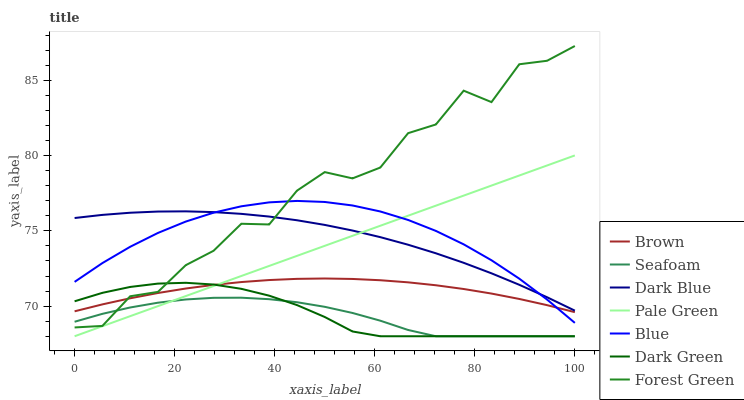Does Seafoam have the minimum area under the curve?
Answer yes or no. Yes. Does Forest Green have the maximum area under the curve?
Answer yes or no. Yes. Does Brown have the minimum area under the curve?
Answer yes or no. No. Does Brown have the maximum area under the curve?
Answer yes or no. No. Is Pale Green the smoothest?
Answer yes or no. Yes. Is Forest Green the roughest?
Answer yes or no. Yes. Is Brown the smoothest?
Answer yes or no. No. Is Brown the roughest?
Answer yes or no. No. Does Brown have the lowest value?
Answer yes or no. No. Does Forest Green have the highest value?
Answer yes or no. Yes. Does Brown have the highest value?
Answer yes or no. No. Is Dark Green less than Blue?
Answer yes or no. Yes. Is Dark Blue greater than Brown?
Answer yes or no. Yes. Does Pale Green intersect Seafoam?
Answer yes or no. Yes. Is Pale Green less than Seafoam?
Answer yes or no. No. Is Pale Green greater than Seafoam?
Answer yes or no. No. Does Dark Green intersect Blue?
Answer yes or no. No. 